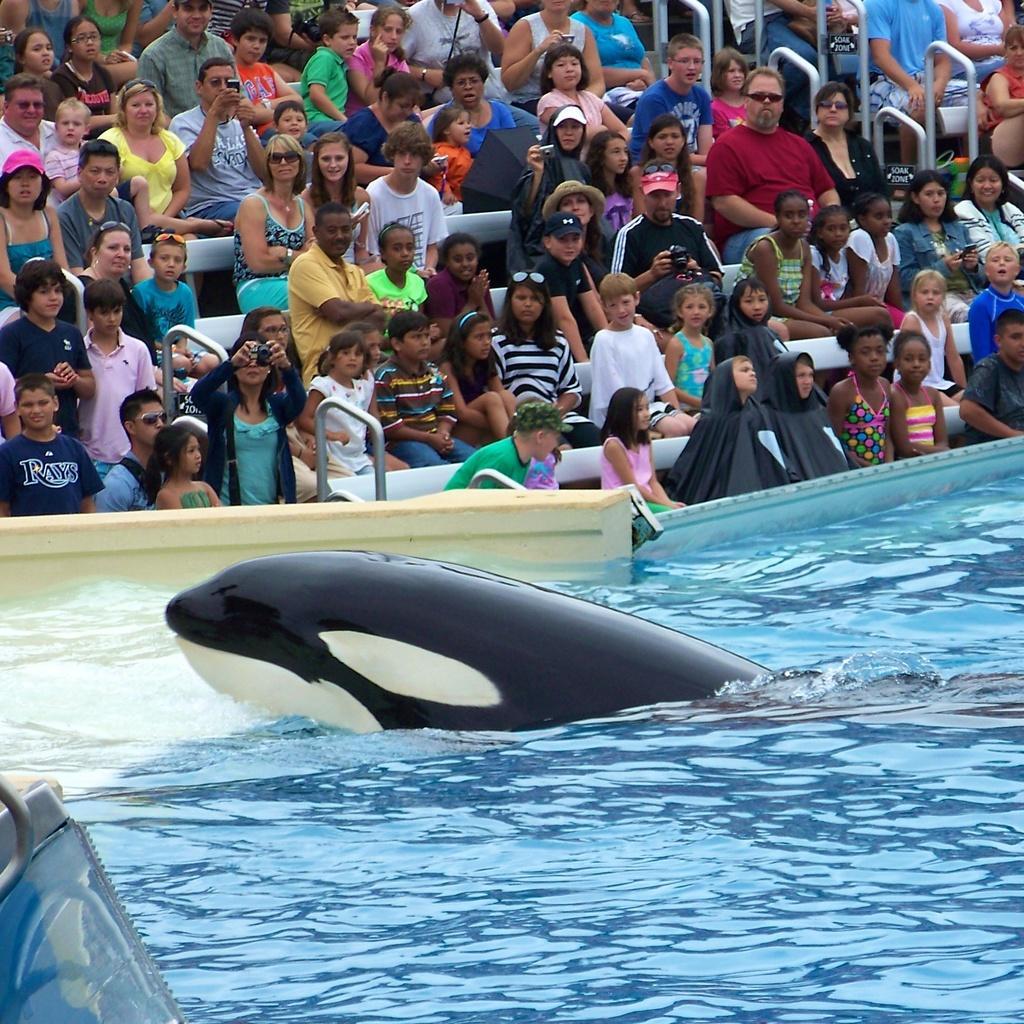Describe this image in one or two sentences. In this we can see a dolphin in the pool, behind people are sitting and watching the show and some people are clicking photographs. 